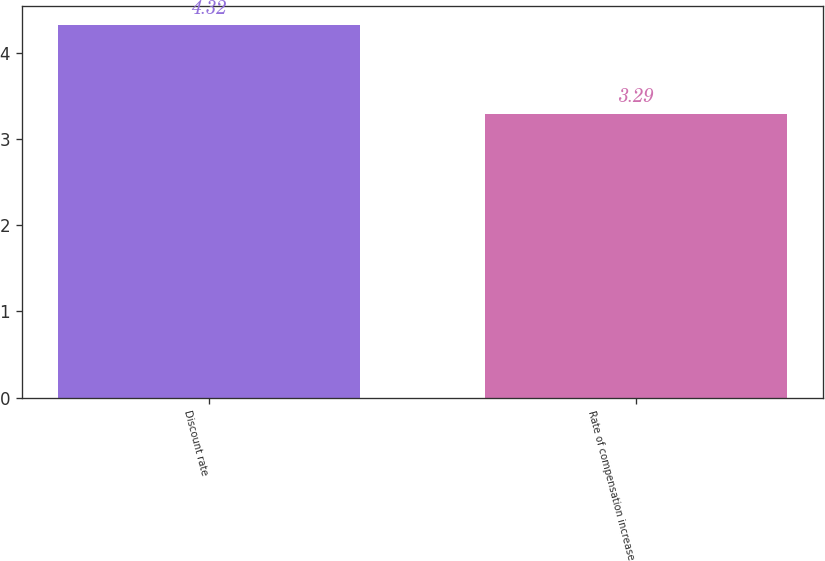Convert chart. <chart><loc_0><loc_0><loc_500><loc_500><bar_chart><fcel>Discount rate<fcel>Rate of compensation increase<nl><fcel>4.32<fcel>3.29<nl></chart> 